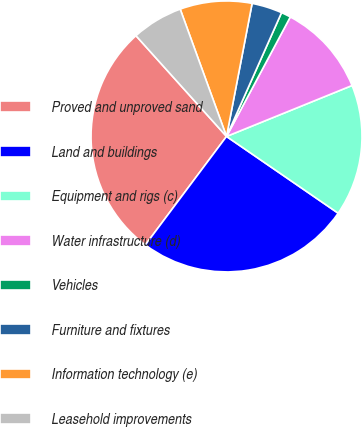Convert chart to OTSL. <chart><loc_0><loc_0><loc_500><loc_500><pie_chart><fcel>Proved and unproved sand<fcel>Land and buildings<fcel>Equipment and rigs (c)<fcel>Water infrastructure (d)<fcel>Vehicles<fcel>Furniture and fixtures<fcel>Information technology (e)<fcel>Leasehold improvements<nl><fcel>28.12%<fcel>25.64%<fcel>15.72%<fcel>11.06%<fcel>1.15%<fcel>3.63%<fcel>8.58%<fcel>6.1%<nl></chart> 